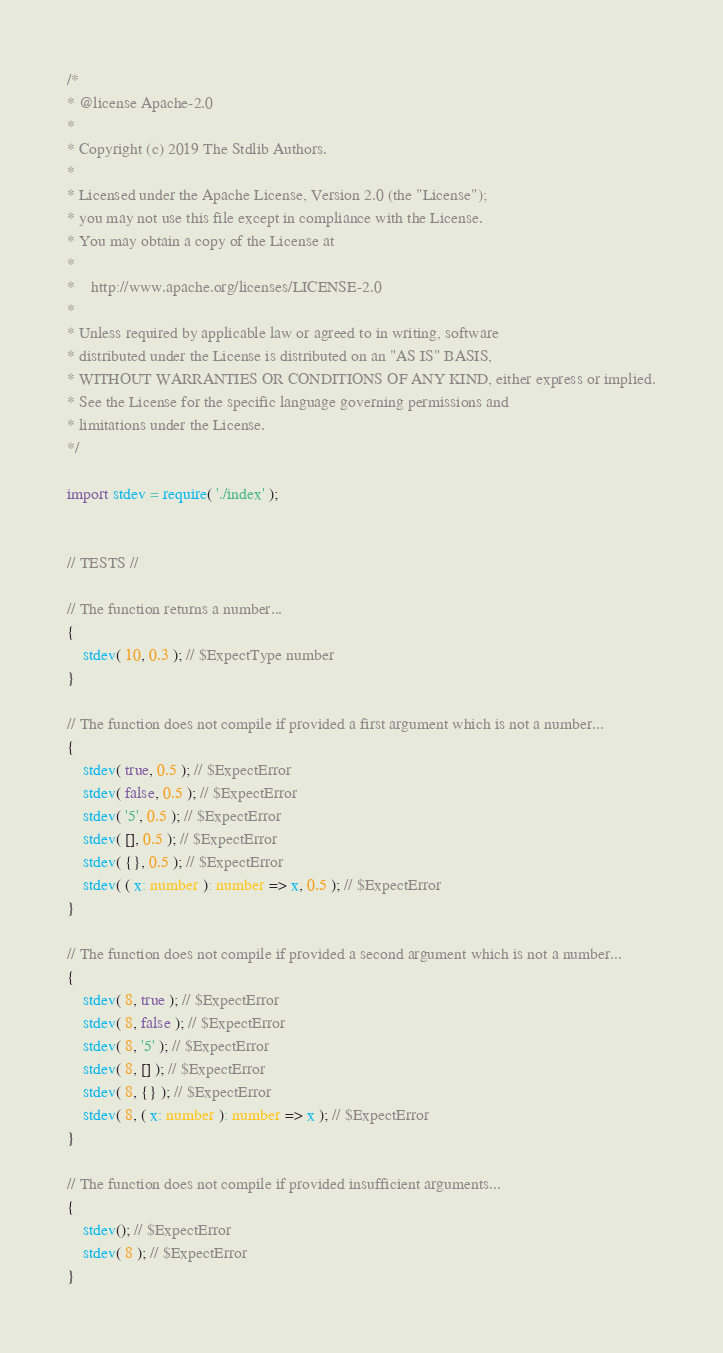Convert code to text. <code><loc_0><loc_0><loc_500><loc_500><_TypeScript_>/*
* @license Apache-2.0
*
* Copyright (c) 2019 The Stdlib Authors.
*
* Licensed under the Apache License, Version 2.0 (the "License");
* you may not use this file except in compliance with the License.
* You may obtain a copy of the License at
*
*    http://www.apache.org/licenses/LICENSE-2.0
*
* Unless required by applicable law or agreed to in writing, software
* distributed under the License is distributed on an "AS IS" BASIS,
* WITHOUT WARRANTIES OR CONDITIONS OF ANY KIND, either express or implied.
* See the License for the specific language governing permissions and
* limitations under the License.
*/

import stdev = require( './index' );


// TESTS //

// The function returns a number...
{
	stdev( 10, 0.3 ); // $ExpectType number
}

// The function does not compile if provided a first argument which is not a number...
{
	stdev( true, 0.5 ); // $ExpectError
	stdev( false, 0.5 ); // $ExpectError
	stdev( '5', 0.5 ); // $ExpectError
	stdev( [], 0.5 ); // $ExpectError
	stdev( {}, 0.5 ); // $ExpectError
	stdev( ( x: number ): number => x, 0.5 ); // $ExpectError
}

// The function does not compile if provided a second argument which is not a number...
{
	stdev( 8, true ); // $ExpectError
	stdev( 8, false ); // $ExpectError
	stdev( 8, '5' ); // $ExpectError
	stdev( 8, [] ); // $ExpectError
	stdev( 8, {} ); // $ExpectError
	stdev( 8, ( x: number ): number => x ); // $ExpectError
}

// The function does not compile if provided insufficient arguments...
{
	stdev(); // $ExpectError
	stdev( 8 ); // $ExpectError
}
</code> 